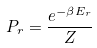<formula> <loc_0><loc_0><loc_500><loc_500>P _ { r } = \frac { e ^ { - \beta E _ { r } } } { Z }</formula> 